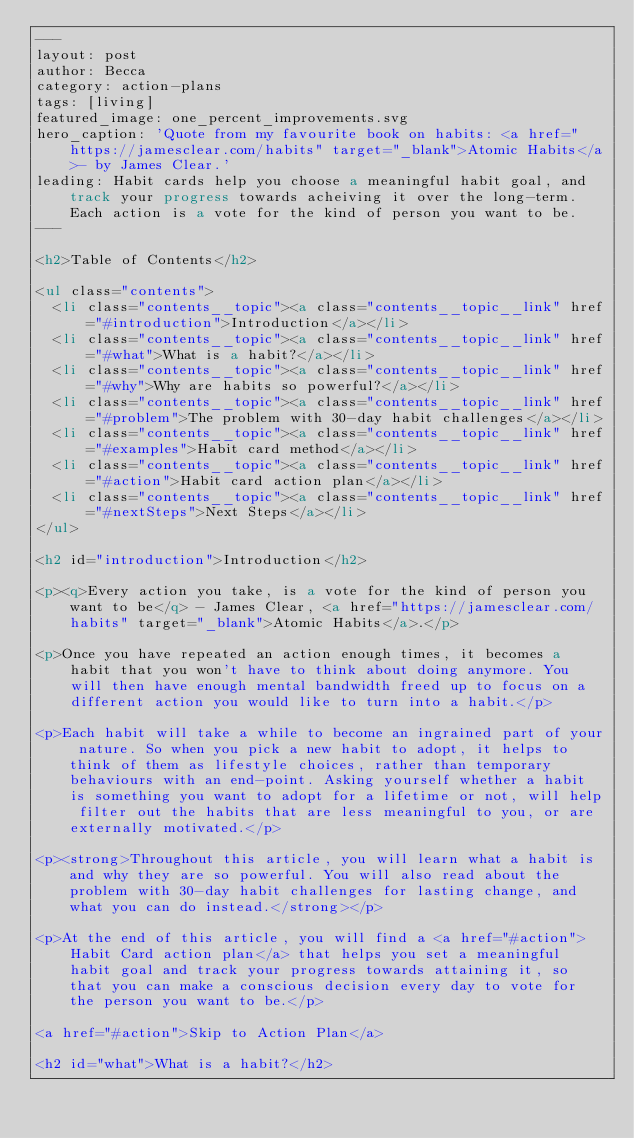Convert code to text. <code><loc_0><loc_0><loc_500><loc_500><_HTML_>---
layout: post
author: Becca
category: action-plans
tags: [living]
featured_image: one_percent_improvements.svg
hero_caption: 'Quote from my favourite book on habits: <a href="https://jamesclear.com/habits" target="_blank">Atomic Habits</a>- by James Clear.'
leading: Habit cards help you choose a meaningful habit goal, and track your progress towards acheiving it over the long-term. Each action is a vote for the kind of person you want to be.
---

<h2>Table of Contents</h2>

<ul class="contents">
  <li class="contents__topic"><a class="contents__topic__link" href="#introduction">Introduction</a></li>
  <li class="contents__topic"><a class="contents__topic__link" href="#what">What is a habit?</a></li>
  <li class="contents__topic"><a class="contents__topic__link" href="#why">Why are habits so powerful?</a></li>
  <li class="contents__topic"><a class="contents__topic__link" href="#problem">The problem with 30-day habit challenges</a></li>
  <li class="contents__topic"><a class="contents__topic__link" href="#examples">Habit card method</a></li>
  <li class="contents__topic"><a class="contents__topic__link" href="#action">Habit card action plan</a></li>
  <li class="contents__topic"><a class="contents__topic__link" href="#nextSteps">Next Steps</a></li>
</ul>

<h2 id="introduction">Introduction</h2>

<p><q>Every action you take, is a vote for the kind of person you want to be</q> - James Clear, <a href="https://jamesclear.com/habits" target="_blank">Atomic Habits</a>.</p>

<p>Once you have repeated an action enough times, it becomes a habit that you won't have to think about doing anymore. You will then have enough mental bandwidth freed up to focus on a different action you would like to turn into a habit.</p>

<p>Each habit will take a while to become an ingrained part of your nature. So when you pick a new habit to adopt, it helps to think of them as lifestyle choices, rather than temporary behaviours with an end-point. Asking yourself whether a habit is something you want to adopt for a lifetime or not, will help filter out the habits that are less meaningful to you, or are externally motivated.</p>

<p><strong>Throughout this article, you will learn what a habit is and why they are so powerful. You will also read about the problem with 30-day habit challenges for lasting change, and what you can do instead.</strong></p>

<p>At the end of this article, you will find a <a href="#action">Habit Card action plan</a> that helps you set a meaningful habit goal and track your progress towards attaining it, so that you can make a conscious decision every day to vote for the person you want to be.</p>

<a href="#action">Skip to Action Plan</a>

<h2 id="what">What is a habit?</h2>
</code> 